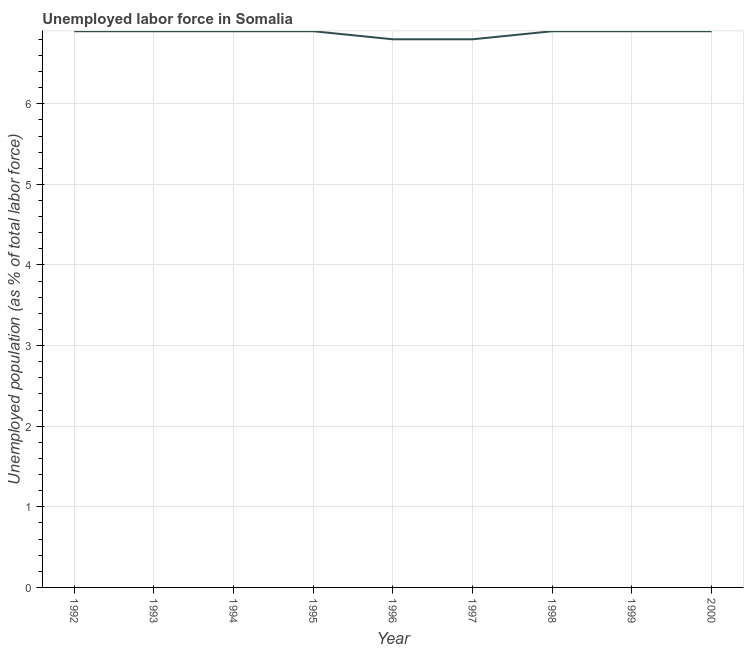What is the total unemployed population in 1997?
Provide a succinct answer. 6.8. Across all years, what is the maximum total unemployed population?
Give a very brief answer. 6.9. Across all years, what is the minimum total unemployed population?
Make the answer very short. 6.8. What is the sum of the total unemployed population?
Offer a terse response. 61.9. What is the difference between the total unemployed population in 1993 and 1997?
Offer a terse response. 0.1. What is the average total unemployed population per year?
Make the answer very short. 6.88. What is the median total unemployed population?
Provide a short and direct response. 6.9. In how many years, is the total unemployed population greater than 5.6 %?
Keep it short and to the point. 9. Is the sum of the total unemployed population in 1992 and 1996 greater than the maximum total unemployed population across all years?
Your response must be concise. Yes. What is the difference between the highest and the lowest total unemployed population?
Make the answer very short. 0.1. Does the total unemployed population monotonically increase over the years?
Your answer should be compact. No. How many lines are there?
Offer a very short reply. 1. Are the values on the major ticks of Y-axis written in scientific E-notation?
Offer a terse response. No. Does the graph contain any zero values?
Offer a terse response. No. Does the graph contain grids?
Provide a short and direct response. Yes. What is the title of the graph?
Your answer should be compact. Unemployed labor force in Somalia. What is the label or title of the Y-axis?
Your answer should be compact. Unemployed population (as % of total labor force). What is the Unemployed population (as % of total labor force) in 1992?
Provide a short and direct response. 6.9. What is the Unemployed population (as % of total labor force) in 1993?
Offer a terse response. 6.9. What is the Unemployed population (as % of total labor force) of 1994?
Provide a succinct answer. 6.9. What is the Unemployed population (as % of total labor force) of 1995?
Your answer should be very brief. 6.9. What is the Unemployed population (as % of total labor force) in 1996?
Provide a succinct answer. 6.8. What is the Unemployed population (as % of total labor force) of 1997?
Offer a terse response. 6.8. What is the Unemployed population (as % of total labor force) in 1998?
Your response must be concise. 6.9. What is the Unemployed population (as % of total labor force) in 1999?
Your answer should be compact. 6.9. What is the Unemployed population (as % of total labor force) in 2000?
Offer a terse response. 6.9. What is the difference between the Unemployed population (as % of total labor force) in 1992 and 1993?
Your answer should be very brief. 0. What is the difference between the Unemployed population (as % of total labor force) in 1992 and 1995?
Ensure brevity in your answer.  0. What is the difference between the Unemployed population (as % of total labor force) in 1992 and 1998?
Make the answer very short. 0. What is the difference between the Unemployed population (as % of total labor force) in 1993 and 1994?
Offer a very short reply. 0. What is the difference between the Unemployed population (as % of total labor force) in 1993 and 1995?
Provide a succinct answer. 0. What is the difference between the Unemployed population (as % of total labor force) in 1993 and 1996?
Provide a short and direct response. 0.1. What is the difference between the Unemployed population (as % of total labor force) in 1993 and 1997?
Your answer should be very brief. 0.1. What is the difference between the Unemployed population (as % of total labor force) in 1994 and 1996?
Offer a very short reply. 0.1. What is the difference between the Unemployed population (as % of total labor force) in 1994 and 1997?
Keep it short and to the point. 0.1. What is the difference between the Unemployed population (as % of total labor force) in 1994 and 1999?
Make the answer very short. 0. What is the difference between the Unemployed population (as % of total labor force) in 1995 and 1997?
Ensure brevity in your answer.  0.1. What is the difference between the Unemployed population (as % of total labor force) in 1995 and 2000?
Give a very brief answer. 0. What is the difference between the Unemployed population (as % of total labor force) in 1996 and 1998?
Offer a terse response. -0.1. What is the difference between the Unemployed population (as % of total labor force) in 1997 and 1998?
Your answer should be compact. -0.1. What is the difference between the Unemployed population (as % of total labor force) in 1997 and 1999?
Your answer should be very brief. -0.1. What is the difference between the Unemployed population (as % of total labor force) in 1997 and 2000?
Your answer should be very brief. -0.1. What is the ratio of the Unemployed population (as % of total labor force) in 1992 to that in 1993?
Provide a succinct answer. 1. What is the ratio of the Unemployed population (as % of total labor force) in 1992 to that in 1994?
Your response must be concise. 1. What is the ratio of the Unemployed population (as % of total labor force) in 1992 to that in 1996?
Give a very brief answer. 1.01. What is the ratio of the Unemployed population (as % of total labor force) in 1993 to that in 1994?
Make the answer very short. 1. What is the ratio of the Unemployed population (as % of total labor force) in 1993 to that in 1995?
Keep it short and to the point. 1. What is the ratio of the Unemployed population (as % of total labor force) in 1993 to that in 1998?
Keep it short and to the point. 1. What is the ratio of the Unemployed population (as % of total labor force) in 1993 to that in 2000?
Your answer should be very brief. 1. What is the ratio of the Unemployed population (as % of total labor force) in 1994 to that in 1996?
Offer a terse response. 1.01. What is the ratio of the Unemployed population (as % of total labor force) in 1994 to that in 1997?
Offer a terse response. 1.01. What is the ratio of the Unemployed population (as % of total labor force) in 1994 to that in 2000?
Your answer should be very brief. 1. What is the ratio of the Unemployed population (as % of total labor force) in 1995 to that in 1996?
Provide a succinct answer. 1.01. What is the ratio of the Unemployed population (as % of total labor force) in 1995 to that in 1997?
Keep it short and to the point. 1.01. What is the ratio of the Unemployed population (as % of total labor force) in 1995 to that in 1998?
Your answer should be very brief. 1. What is the ratio of the Unemployed population (as % of total labor force) in 1996 to that in 1997?
Ensure brevity in your answer.  1. What is the ratio of the Unemployed population (as % of total labor force) in 1996 to that in 1998?
Your response must be concise. 0.99. What is the ratio of the Unemployed population (as % of total labor force) in 1996 to that in 1999?
Your response must be concise. 0.99. What is the ratio of the Unemployed population (as % of total labor force) in 1997 to that in 1998?
Keep it short and to the point. 0.99. What is the ratio of the Unemployed population (as % of total labor force) in 1997 to that in 1999?
Give a very brief answer. 0.99. What is the ratio of the Unemployed population (as % of total labor force) in 1997 to that in 2000?
Your response must be concise. 0.99. 